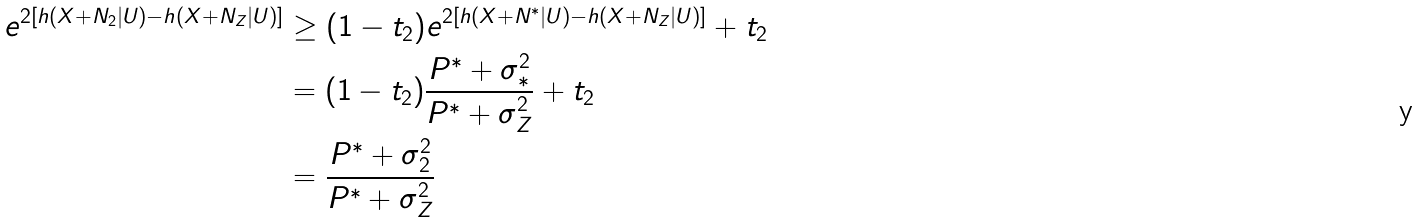<formula> <loc_0><loc_0><loc_500><loc_500>e ^ { 2 \left [ h ( X + N _ { 2 } | U ) - h ( X + N _ { Z } | U ) \right ] } & \geq ( 1 - t _ { 2 } ) e ^ { 2 \left [ h ( X + N ^ { * } | U ) - h ( X + N _ { Z } | U ) \right ] } + t _ { 2 } \\ & = ( 1 - t _ { 2 } ) \frac { P ^ { * } + \sigma _ { * } ^ { 2 } } { P ^ { * } + \sigma _ { Z } ^ { 2 } } + t _ { 2 } \\ & = \frac { P ^ { * } + \sigma _ { 2 } ^ { 2 } } { P ^ { * } + \sigma _ { Z } ^ { 2 } }</formula> 